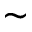<formula> <loc_0><loc_0><loc_500><loc_500>\sim</formula> 